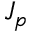<formula> <loc_0><loc_0><loc_500><loc_500>J _ { p }</formula> 